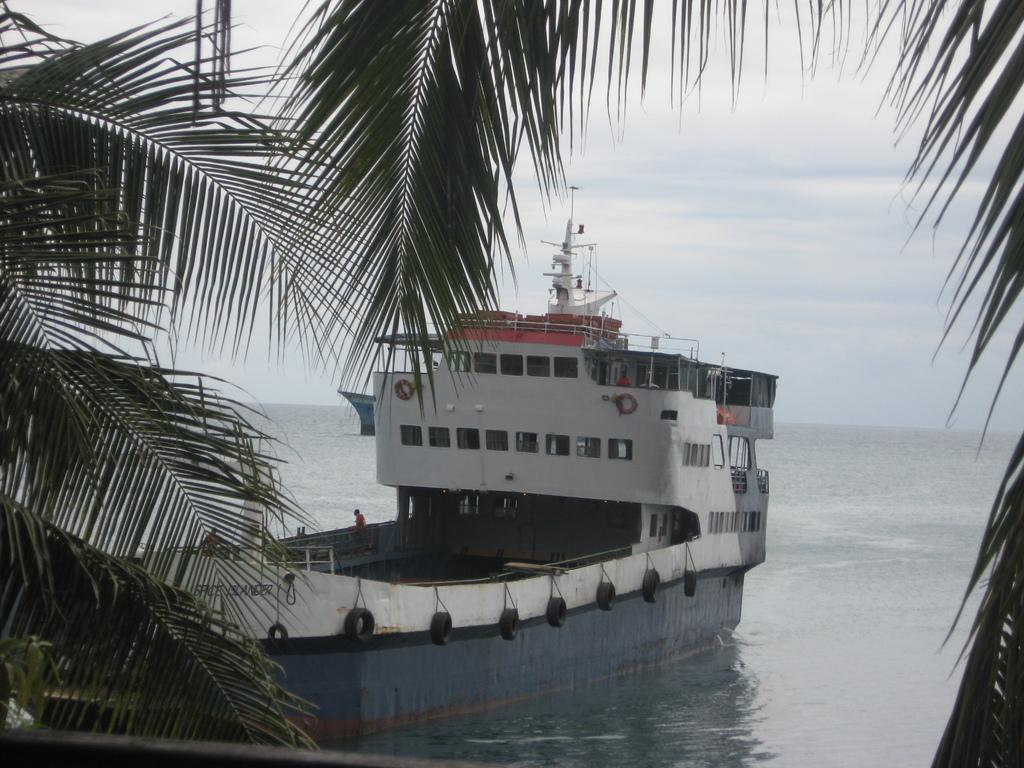What is the main subject of the image? The main subject of the image is a ship. Where is the ship located in the image? The ship is on the water in the image. Are there any people on the ship? Yes, there are people in the ship. What feature can be seen on the ship? The ship has windows. What can be seen in the background of the image? Trees and the sky are visible in the background of the image. What type of ornament is being used by the servant on the ship? There is no ornament or servant present in the image; it features a ship on the water with people on board. What day of the week is it in the image? The day of the week cannot be determined from the image, as it only shows a ship on the water with people on board. 